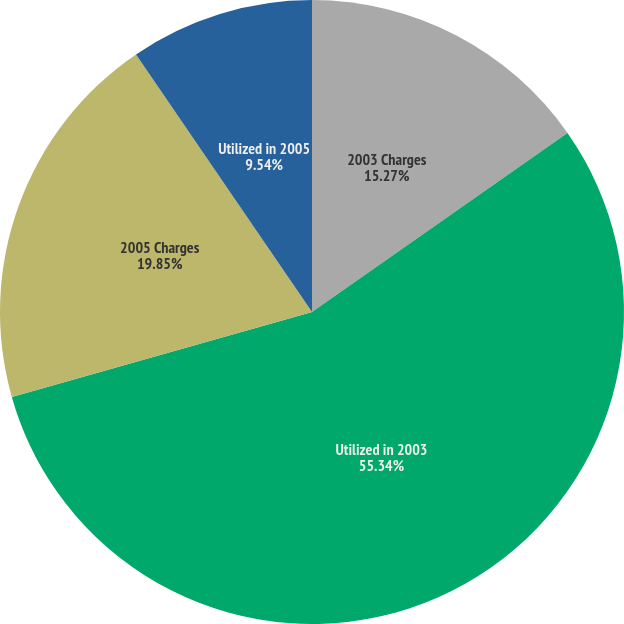Convert chart. <chart><loc_0><loc_0><loc_500><loc_500><pie_chart><fcel>2003 Charges<fcel>Utilized in 2003<fcel>2005 Charges<fcel>Utilized in 2005<nl><fcel>15.27%<fcel>55.34%<fcel>19.85%<fcel>9.54%<nl></chart> 